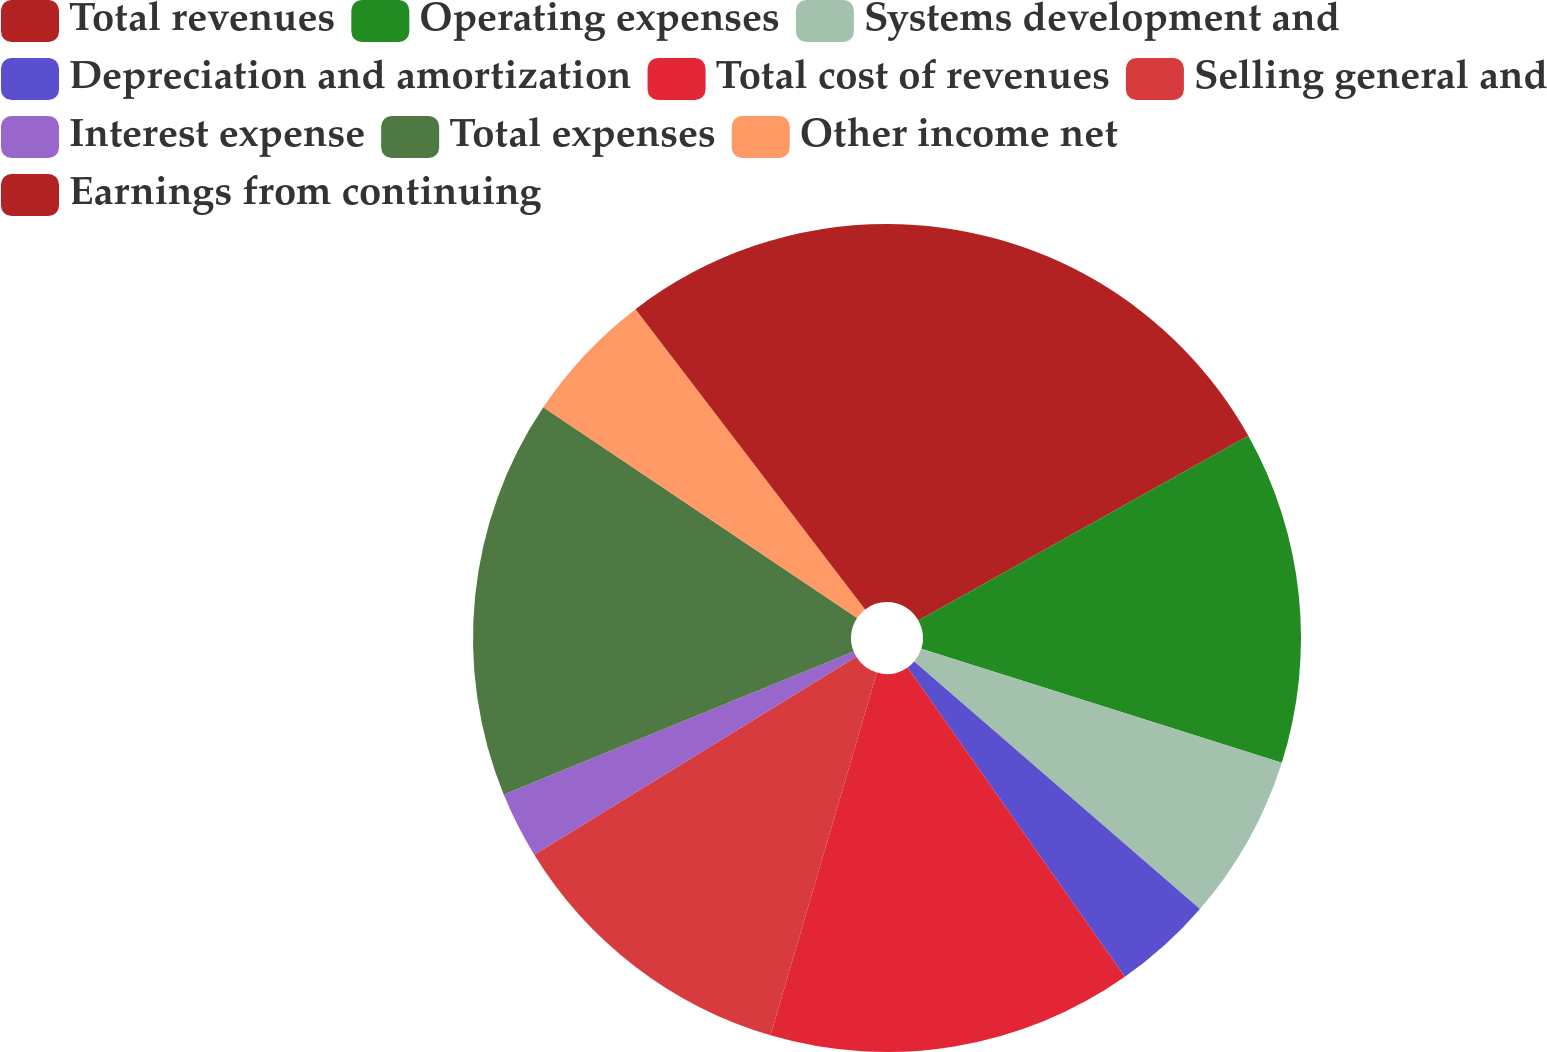Convert chart. <chart><loc_0><loc_0><loc_500><loc_500><pie_chart><fcel>Total revenues<fcel>Operating expenses<fcel>Systems development and<fcel>Depreciation and amortization<fcel>Total cost of revenues<fcel>Selling general and<fcel>Interest expense<fcel>Total expenses<fcel>Other income net<fcel>Earnings from continuing<nl><fcel>16.88%<fcel>12.99%<fcel>6.49%<fcel>3.9%<fcel>14.28%<fcel>11.69%<fcel>2.6%<fcel>15.58%<fcel>5.2%<fcel>10.39%<nl></chart> 